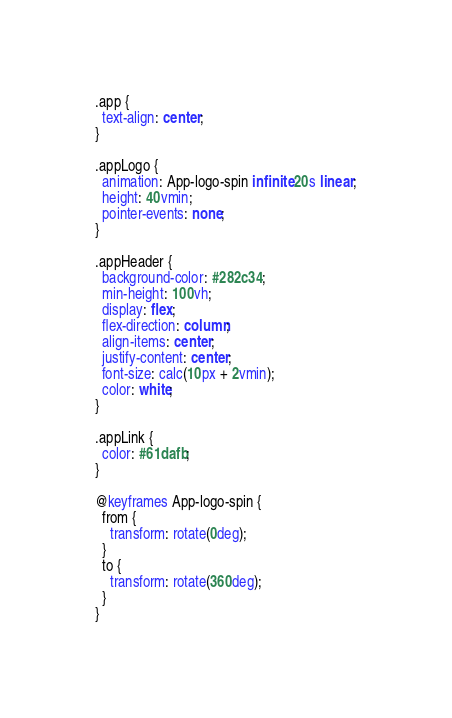<code> <loc_0><loc_0><loc_500><loc_500><_CSS_>.app {
  text-align: center;
}

.appLogo {
  animation: App-logo-spin infinite 20s linear;
  height: 40vmin;
  pointer-events: none;
}

.appHeader {
  background-color: #282c34;
  min-height: 100vh;
  display: flex;
  flex-direction: column;
  align-items: center;
  justify-content: center;
  font-size: calc(10px + 2vmin);
  color: white;
}

.appLink {
  color: #61dafb;
}

@keyframes App-logo-spin {
  from {
    transform: rotate(0deg);
  }
  to {
    transform: rotate(360deg);
  }
}
</code> 